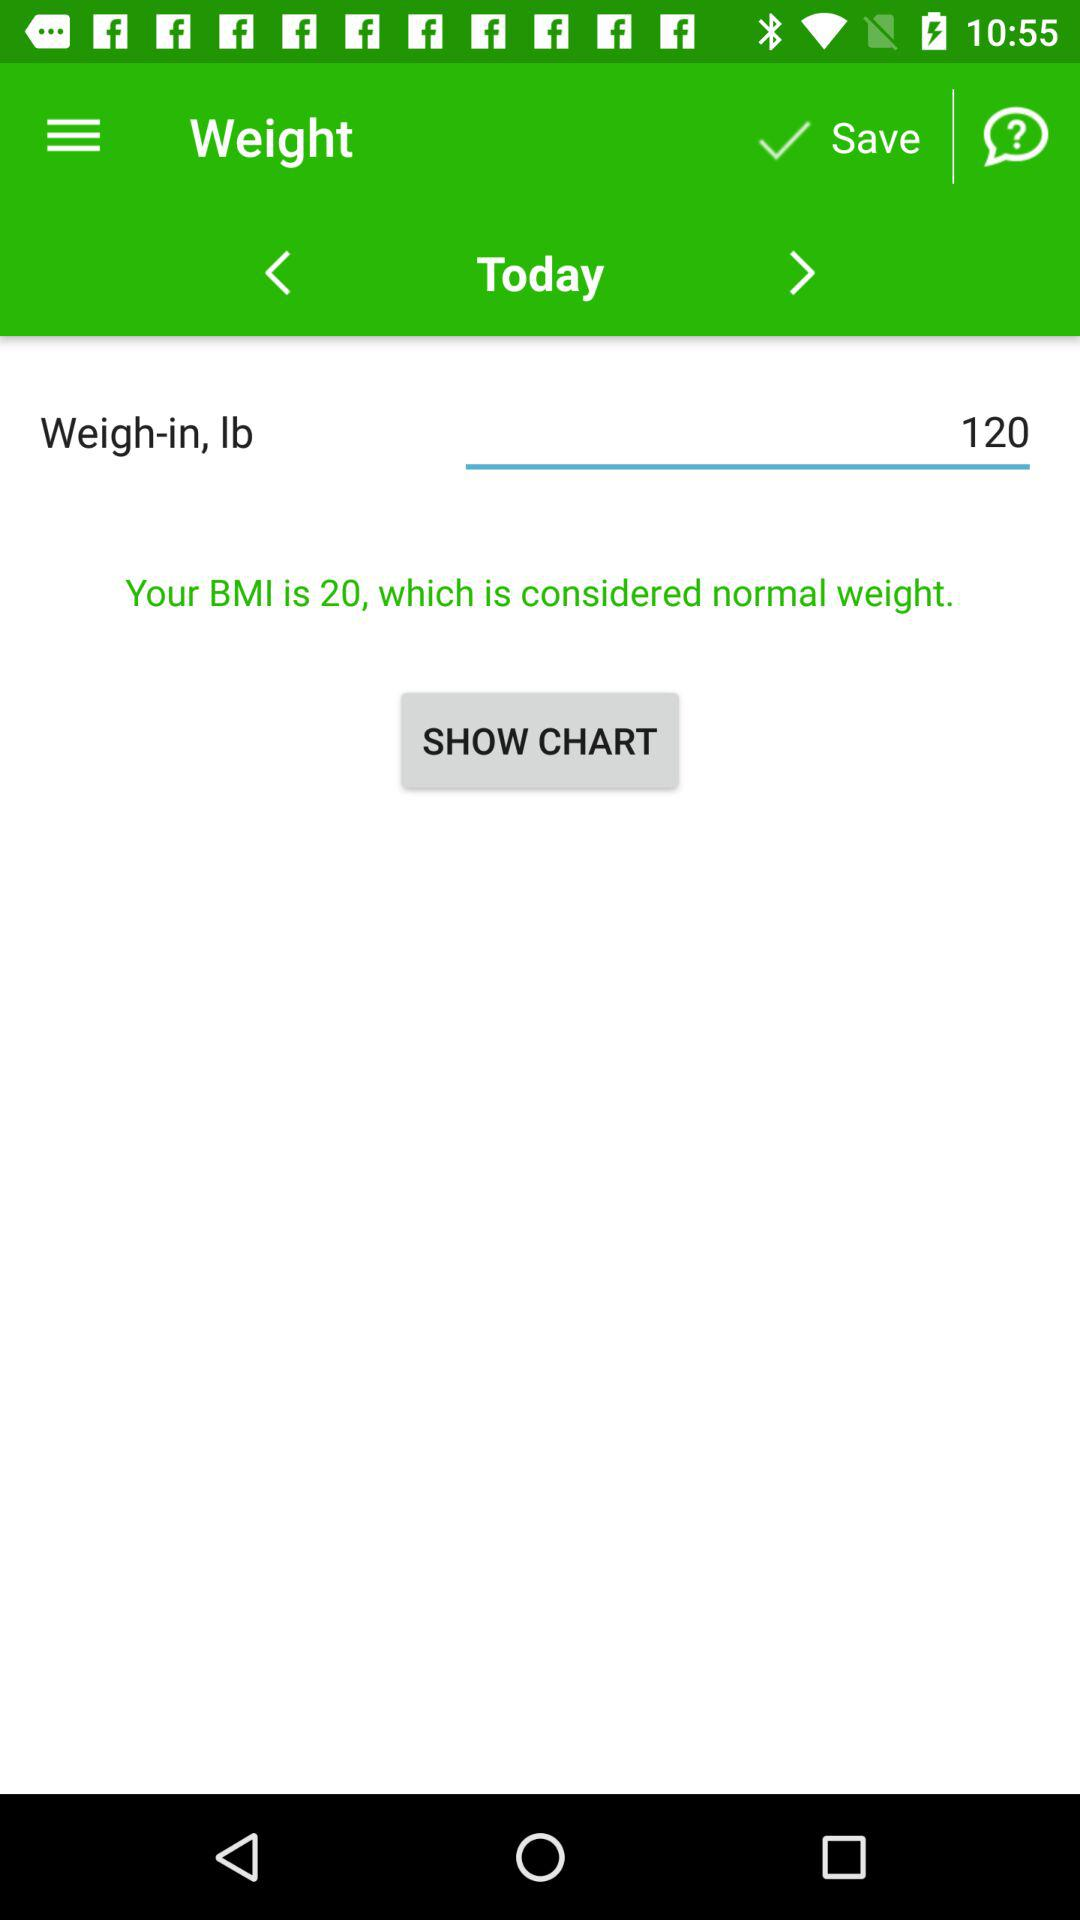What is the given BMI? The given BMI is 20. 